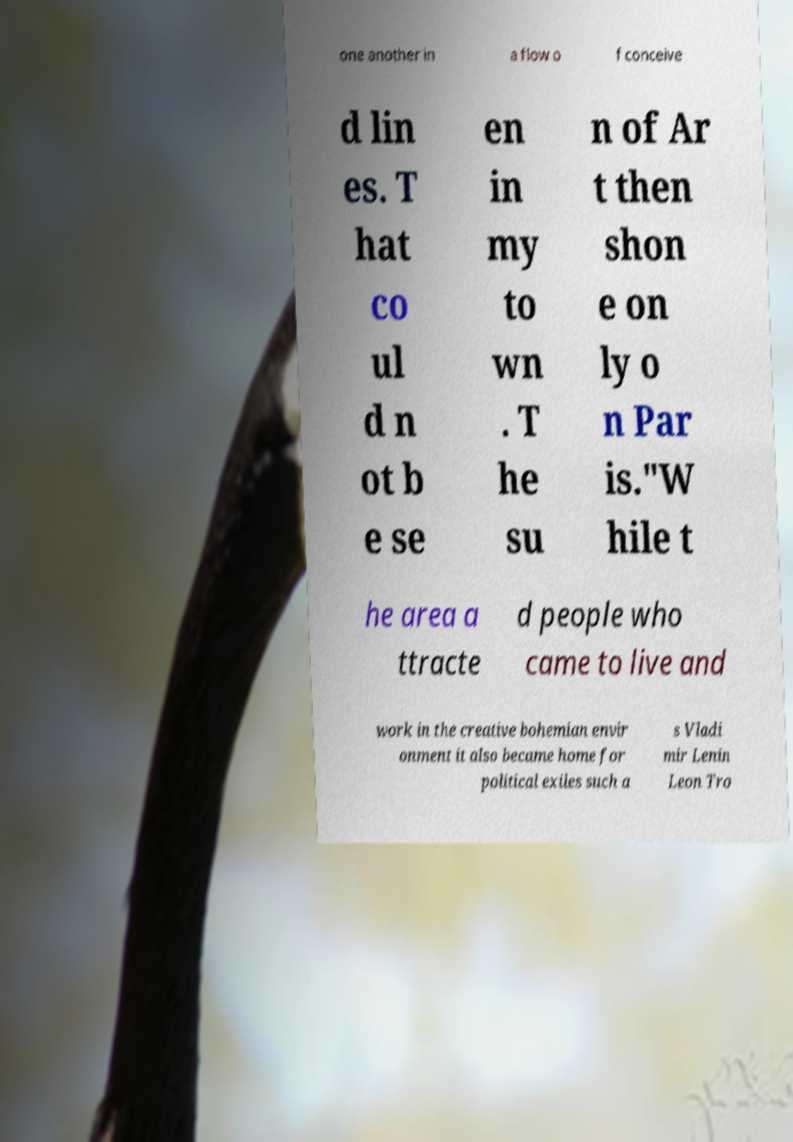What messages or text are displayed in this image? I need them in a readable, typed format. one another in a flow o f conceive d lin es. T hat co ul d n ot b e se en in my to wn . T he su n of Ar t then shon e on ly o n Par is."W hile t he area a ttracte d people who came to live and work in the creative bohemian envir onment it also became home for political exiles such a s Vladi mir Lenin Leon Tro 